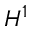<formula> <loc_0><loc_0><loc_500><loc_500>H ^ { 1 }</formula> 